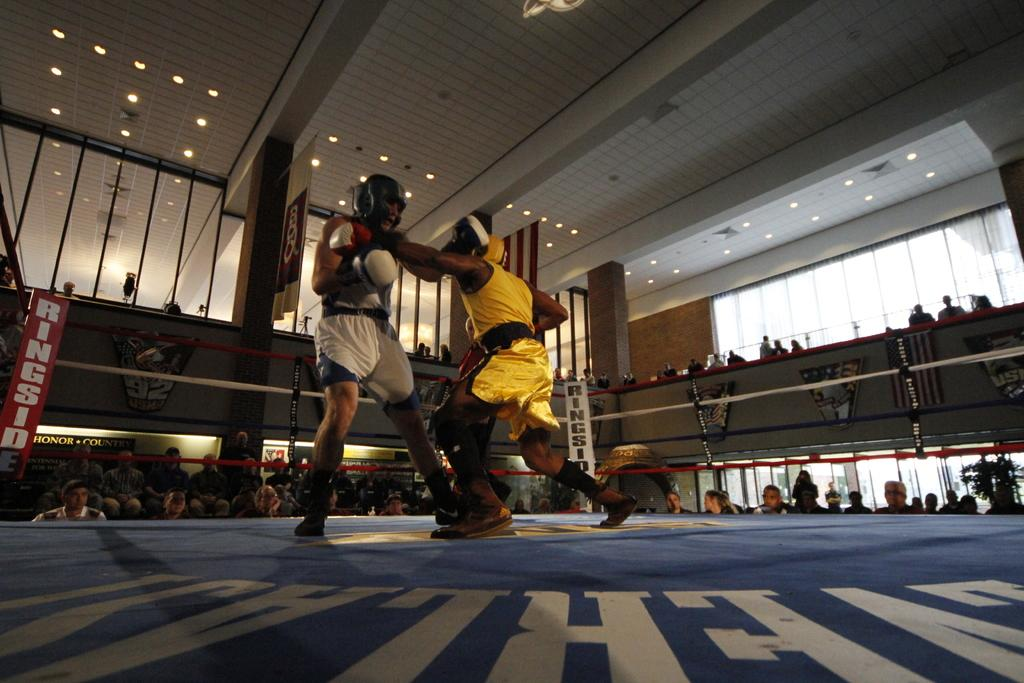<image>
Write a terse but informative summary of the picture. A red and white sign that says RINGSIDE can be seen behind the fighters. 